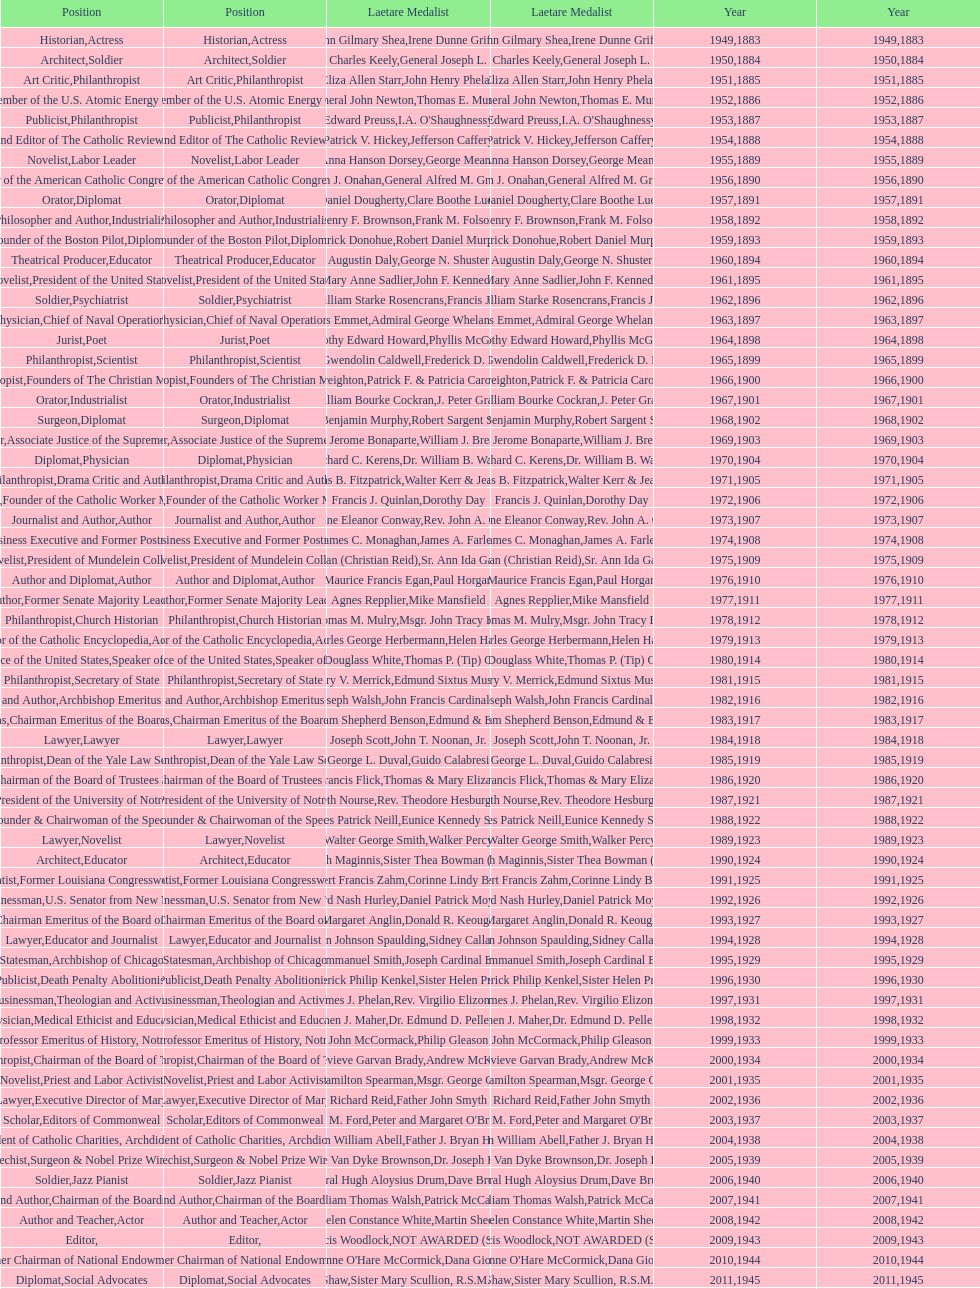Who won the medal after thomas e. murray in 1952? I.A. O'Shaughnessy. 